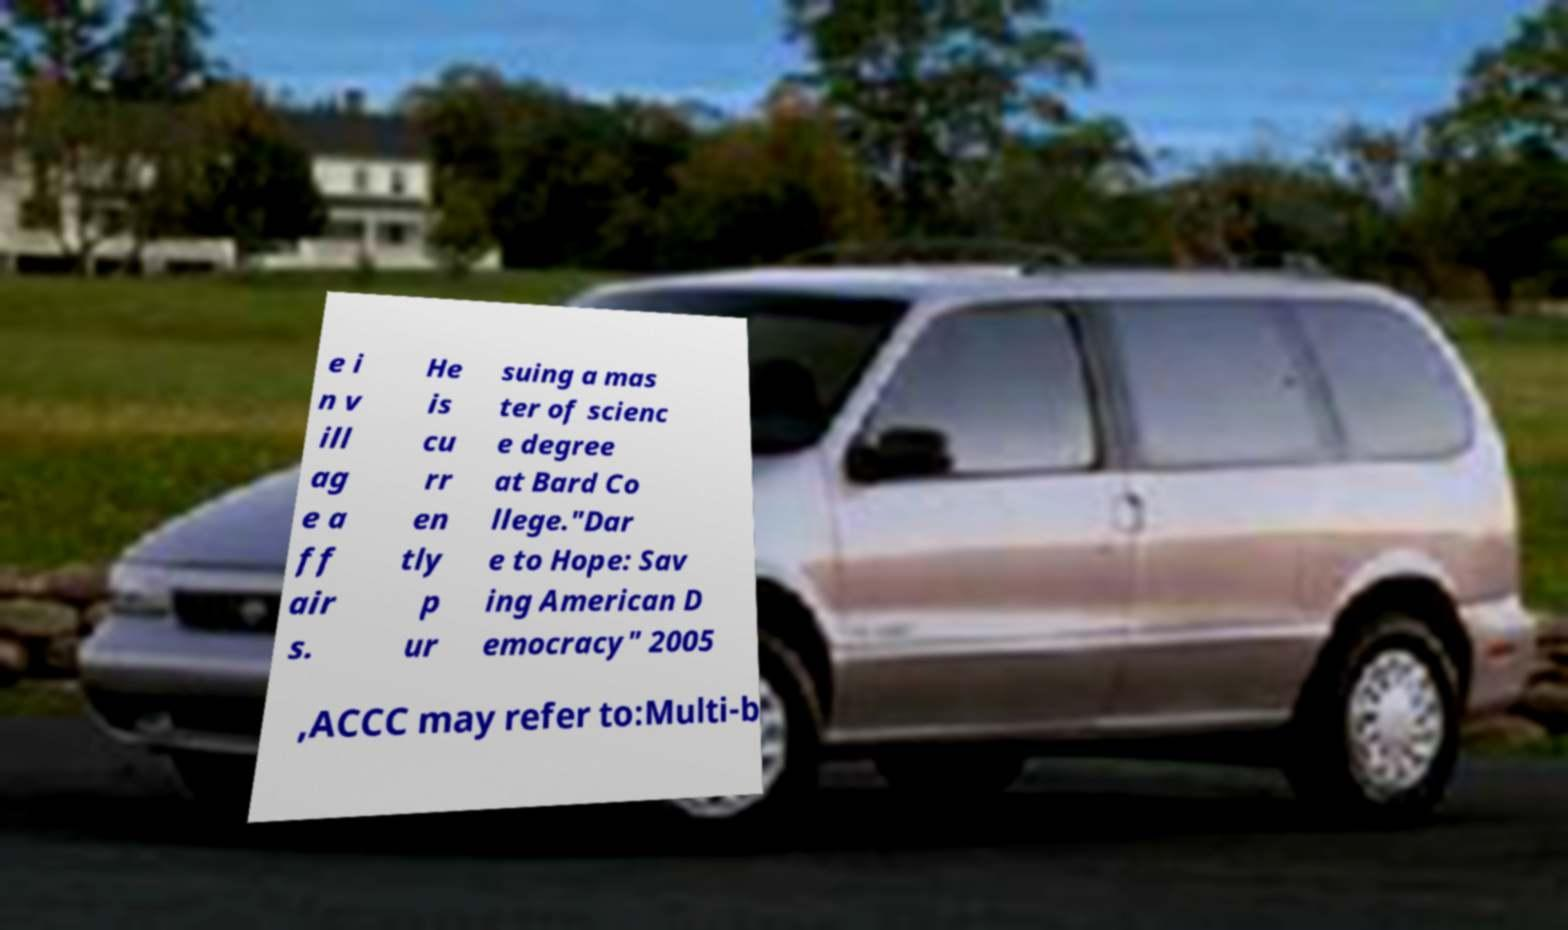I need the written content from this picture converted into text. Can you do that? e i n v ill ag e a ff air s. He is cu rr en tly p ur suing a mas ter of scienc e degree at Bard Co llege."Dar e to Hope: Sav ing American D emocracy" 2005 ,ACCC may refer to:Multi-b 